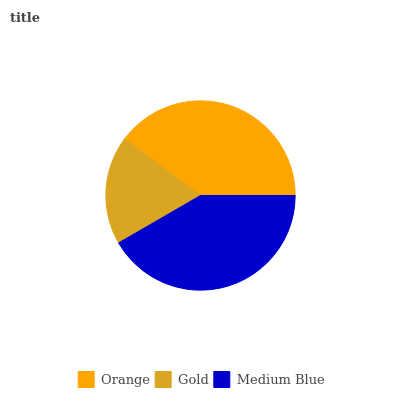Is Gold the minimum?
Answer yes or no. Yes. Is Medium Blue the maximum?
Answer yes or no. Yes. Is Medium Blue the minimum?
Answer yes or no. No. Is Gold the maximum?
Answer yes or no. No. Is Medium Blue greater than Gold?
Answer yes or no. Yes. Is Gold less than Medium Blue?
Answer yes or no. Yes. Is Gold greater than Medium Blue?
Answer yes or no. No. Is Medium Blue less than Gold?
Answer yes or no. No. Is Orange the high median?
Answer yes or no. Yes. Is Orange the low median?
Answer yes or no. Yes. Is Gold the high median?
Answer yes or no. No. Is Medium Blue the low median?
Answer yes or no. No. 